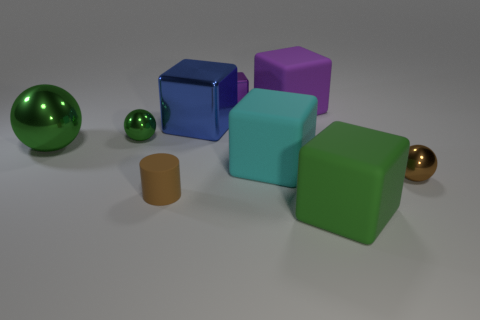Subtract all cyan blocks. How many blocks are left? 4 Subtract all big blue cubes. How many cubes are left? 4 Subtract all red blocks. Subtract all gray cylinders. How many blocks are left? 5 Add 1 small green metallic balls. How many objects exist? 10 Subtract all blocks. How many objects are left? 4 Subtract 0 red blocks. How many objects are left? 9 Subtract all green matte things. Subtract all rubber objects. How many objects are left? 4 Add 5 large shiny spheres. How many large shiny spheres are left? 6 Add 7 large shiny objects. How many large shiny objects exist? 9 